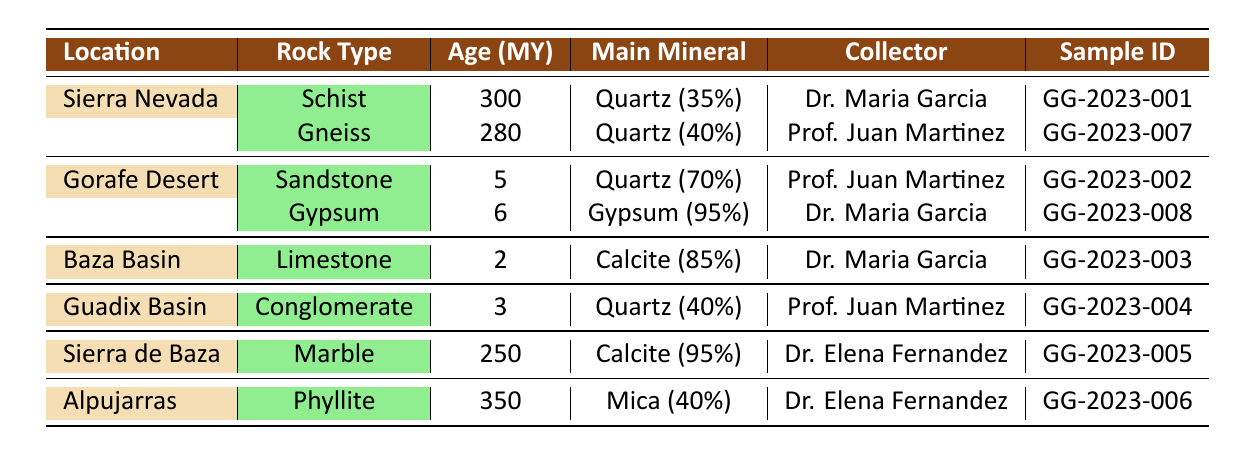What is the rock type of the sample collected from the Baza Basin? The table shows that the sample from the Baza Basin has the rock type listed as Limestone.
Answer: Limestone Which sample has the highest age and what is that age? Looking through the table, I can see that the sample from the Alpujarras is 350 million years old, which is the highest age listed.
Answer: 350 million years Is the main mineral in the Sierra Nevada sample Schist? The table indicates that the main mineral in the Schist sample from Sierra Nevada is Quartz, not Schist itself. Therefore, the statement is false.
Answer: No What is the average age of the samples collected? To find the average age, I sum the ages: (300 + 5 + 2 + 3 + 250 + 350 + 280 + 6) = 896. There are 8 samples, so the average age is 896 / 8 = 112 million years.
Answer: 112 million years Which collector collected the most samples and how many? By checking the collectors listed, Dr. Maria Garcia and Prof. Juan Martinez each have collected 3 samples, while Dr. Elena Fernandez collected 2. Therefore, the highest count (3 samples) belongs to both Dr. Maria Garcia and Prof. Juan Martinez.
Answer: Dr. Maria Garcia and Prof. Juan Martinez, 3 samples each What is the main mineral composition of the sample collected from the Gorafe Desert? The table indicates that the main mineral in the Sandstone sample from the Gorafe Desert is Quartz, which comprises 70% of the composition.
Answer: Quartz (70%) Are there any samples with a rock type of Gypsum in this data set? The table shows that there is indeed a Gypsum sample collected from the Gorafe Desert, confirming that yes, Gypsum is present.
Answer: Yes What is the total percentage of minerals for the Conglomerate sample from Guadix Basin? The mineral composition of the Conglomerate sample is 40% Quartz, 25% Feldspar, 20% Limestone, and 15% Granite. Summing these gives 40 + 25 + 20 + 15 = 100%.
Answer: 100% 